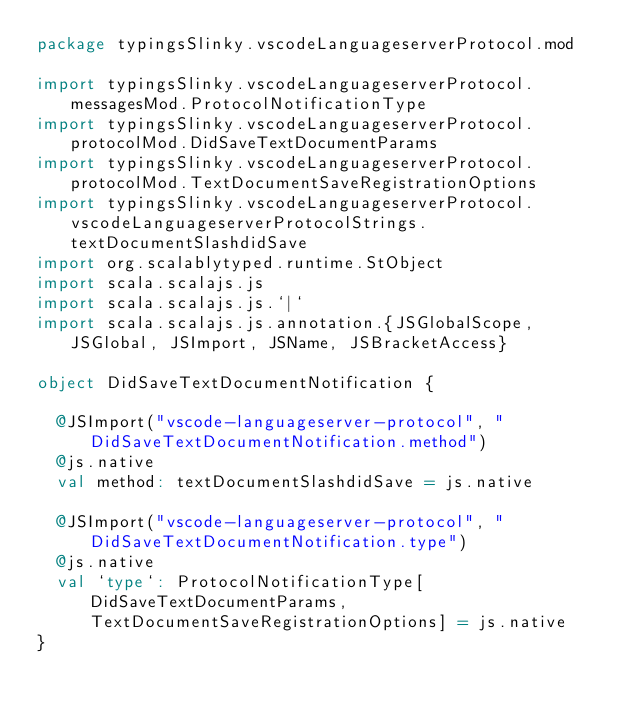<code> <loc_0><loc_0><loc_500><loc_500><_Scala_>package typingsSlinky.vscodeLanguageserverProtocol.mod

import typingsSlinky.vscodeLanguageserverProtocol.messagesMod.ProtocolNotificationType
import typingsSlinky.vscodeLanguageserverProtocol.protocolMod.DidSaveTextDocumentParams
import typingsSlinky.vscodeLanguageserverProtocol.protocolMod.TextDocumentSaveRegistrationOptions
import typingsSlinky.vscodeLanguageserverProtocol.vscodeLanguageserverProtocolStrings.textDocumentSlashdidSave
import org.scalablytyped.runtime.StObject
import scala.scalajs.js
import scala.scalajs.js.`|`
import scala.scalajs.js.annotation.{JSGlobalScope, JSGlobal, JSImport, JSName, JSBracketAccess}

object DidSaveTextDocumentNotification {
  
  @JSImport("vscode-languageserver-protocol", "DidSaveTextDocumentNotification.method")
  @js.native
  val method: textDocumentSlashdidSave = js.native
  
  @JSImport("vscode-languageserver-protocol", "DidSaveTextDocumentNotification.type")
  @js.native
  val `type`: ProtocolNotificationType[DidSaveTextDocumentParams, TextDocumentSaveRegistrationOptions] = js.native
}
</code> 